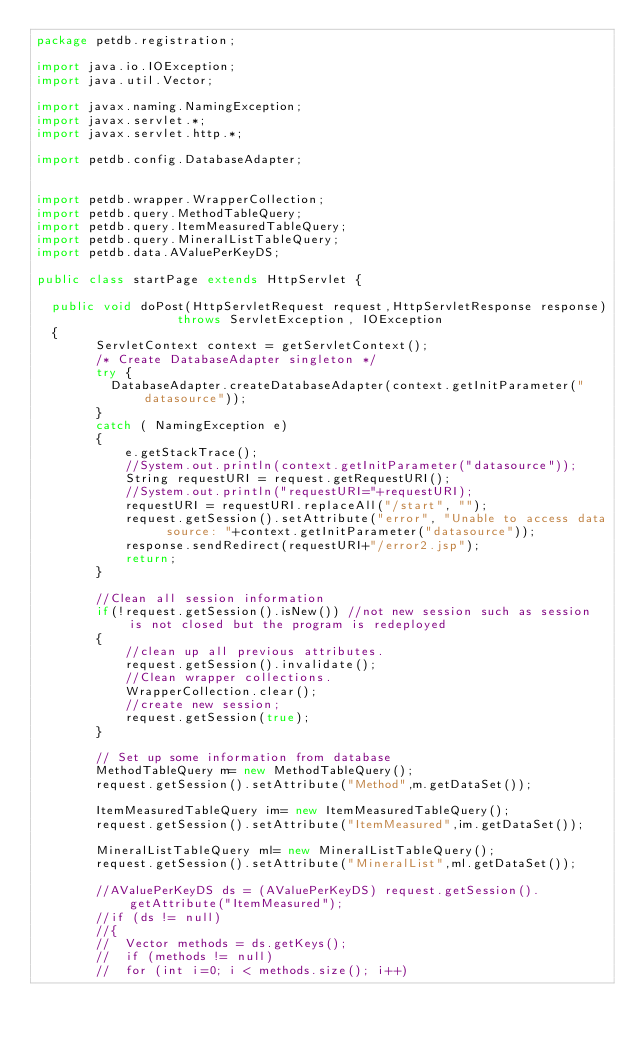Convert code to text. <code><loc_0><loc_0><loc_500><loc_500><_Java_>package petdb.registration;

import java.io.IOException;
import java.util.Vector;

import javax.naming.NamingException;
import javax.servlet.*;
import javax.servlet.http.*;

import petdb.config.DatabaseAdapter;


import petdb.wrapper.WrapperCollection;
import petdb.query.MethodTableQuery;
import petdb.query.ItemMeasuredTableQuery;
import petdb.query.MineralListTableQuery;
import petdb.data.AValuePerKeyDS;

public class startPage extends HttpServlet {
	
  public void doPost(HttpServletRequest request,HttpServletResponse response)
                   throws ServletException, IOException 
  {
		ServletContext context = getServletContext();
        /* Create DatabaseAdapter singleton */
		try {
		  DatabaseAdapter.createDatabaseAdapter(context.getInitParameter("datasource"));
		}
		catch ( NamingException e) 
		{  
			e.getStackTrace();
			//System.out.println(context.getInitParameter("datasource"));
			String requestURI = request.getRequestURI();
			//System.out.println("requestURI="+requestURI);
			requestURI = requestURI.replaceAll("/start", "");
			request.getSession().setAttribute("error", "Unable to access data source: "+context.getInitParameter("datasource"));
			response.sendRedirect(requestURI+"/error2.jsp");
			return;
		}
		
		//Clean all session information
		if(!request.getSession().isNew()) //not new session such as session is not closed but the program is redeployed
		{
			//clean up all previous attributes.
			request.getSession().invalidate(); 
			//Clean wrapper collections.
			WrapperCollection.clear();
			//create new session;
			request.getSession(true);
		}
		
		// Set up some information from database
		MethodTableQuery m= new MethodTableQuery();
		request.getSession().setAttribute("Method",m.getDataSet());
		
		ItemMeasuredTableQuery im= new ItemMeasuredTableQuery();
		request.getSession().setAttribute("ItemMeasured",im.getDataSet());
		
		MineralListTableQuery ml= new MineralListTableQuery();
		request.getSession().setAttribute("MineralList",ml.getDataSet());
		
		//AValuePerKeyDS ds = (AValuePerKeyDS) request.getSession().getAttribute("ItemMeasured");
		//if (ds != null)
		//{
		//	Vector methods = ds.getKeys();
		//	if (methods != null)
		//	for (int i=0; i < methods.size(); i++)</code> 